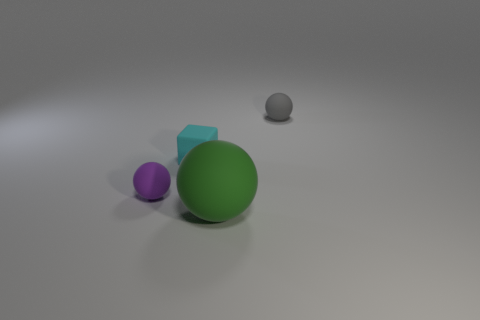There is a rubber block that is the same size as the purple rubber sphere; what is its color?
Give a very brief answer. Cyan. There is a big thing in front of the small purple matte sphere; how many rubber balls are on the left side of it?
Your answer should be very brief. 1. What number of tiny objects are both behind the tiny cyan thing and in front of the gray object?
Provide a succinct answer. 0. How many things are small rubber things to the left of the big matte object or small things that are left of the green thing?
Make the answer very short. 2. What number of other things are there of the same size as the green sphere?
Make the answer very short. 0. The rubber object in front of the tiny sphere on the left side of the cyan rubber block is what shape?
Your answer should be compact. Sphere. Is there any other thing that has the same color as the matte block?
Your response must be concise. No. What is the color of the large rubber object?
Offer a terse response. Green. Are there any large blocks?
Offer a terse response. No. Are there any rubber things to the right of the big ball?
Offer a very short reply. Yes. 